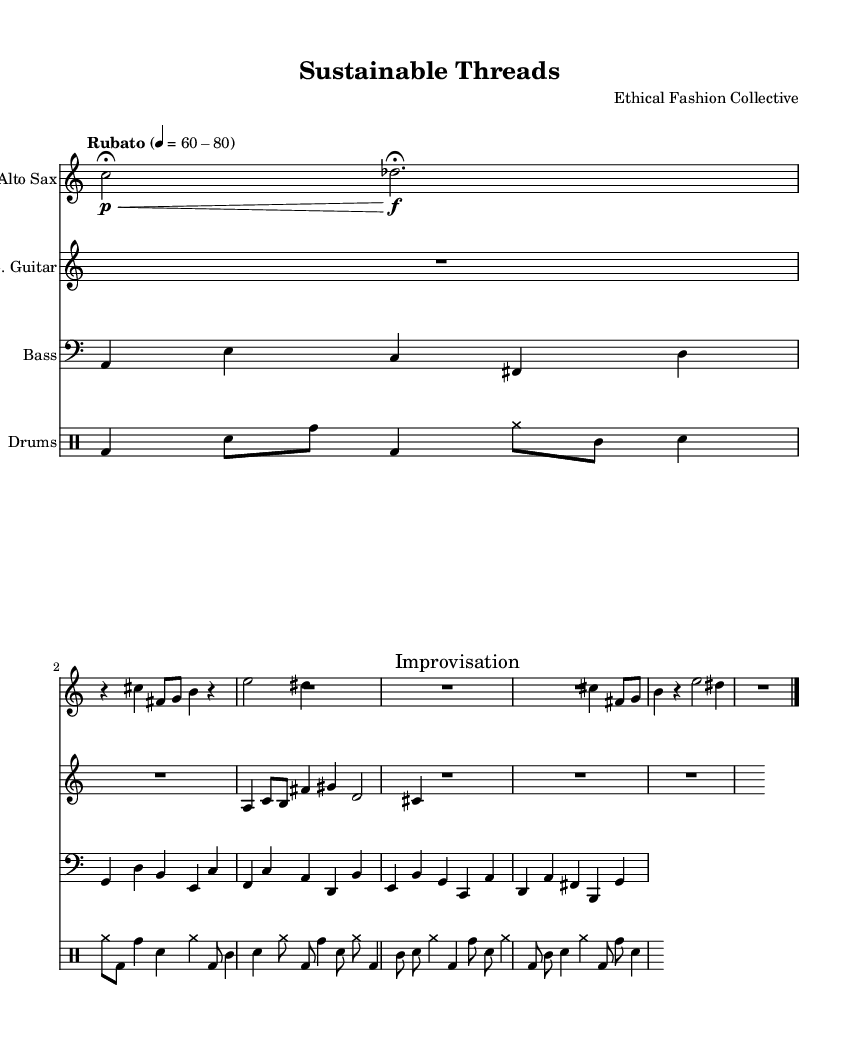What is the time signature of this music? The time signature is indicated as 5/4, which can typically be found at the beginning of the score. This means there are five beats in each measure, and the quarter note gets one beat.
Answer: 5/4 What is the tempo indication for this piece? The tempo is marked as "Rubato" with a range of 60-80. This tells the performer that the piece should be played with a flexible tempo, allowing for expressive timing within that range of beats per minute.
Answer: Rubato 60-80 How many sections are labeled for improvisation? The sheet music shows one clear section labeled "Improvisation," indicating that performers can freely interpret and modify the music during this part.
Answer: 1 What instruments are used in this composition? The score includes alto saxophone, electric guitar, bass, and drums. This can be identified at the beginning of each staff section, where the instrument names are presented.
Answer: Alto Sax, E. Guitar, Bass, Drums Which section contains the recurring Theme A? Theme A is presented multiple times, specifically indicated in the score after the introductory phrases and as a variation. By analyzing the score, it's shown after the "Intro" and less prominently for the variation during improvisation, indicating its significance.
Answer: After Intro and as a Variation What type of rhythmic patterns are present in the drum part? The drum part features irregular patterns with polyrhythms, characterized by varying note values and distinctive drum notations for bass drum, snare, and toms. This complexity is highlighted across the multiple measures in the drum staff.
Answer: Irregular patterns with polyrhythms 